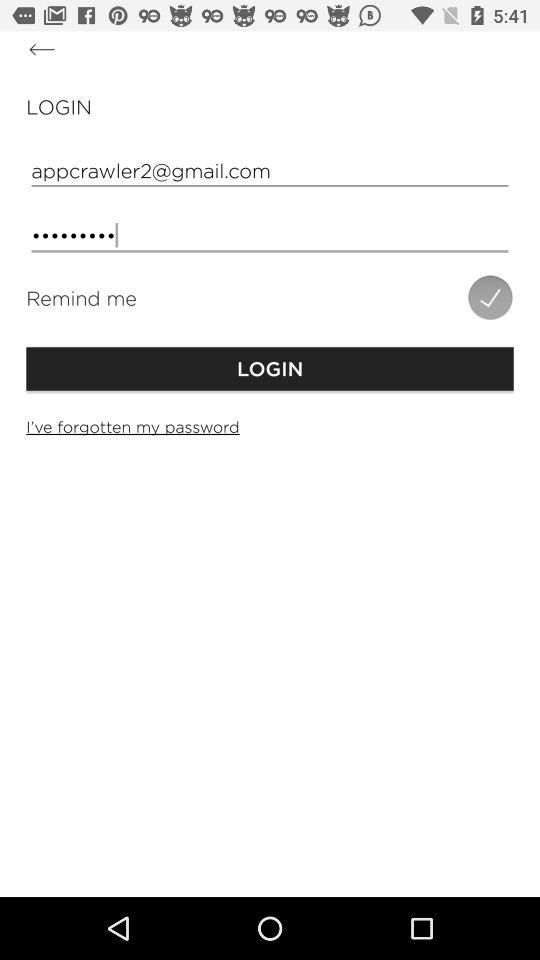What is the email address? The email address is appcrawler2@gmail.com. 